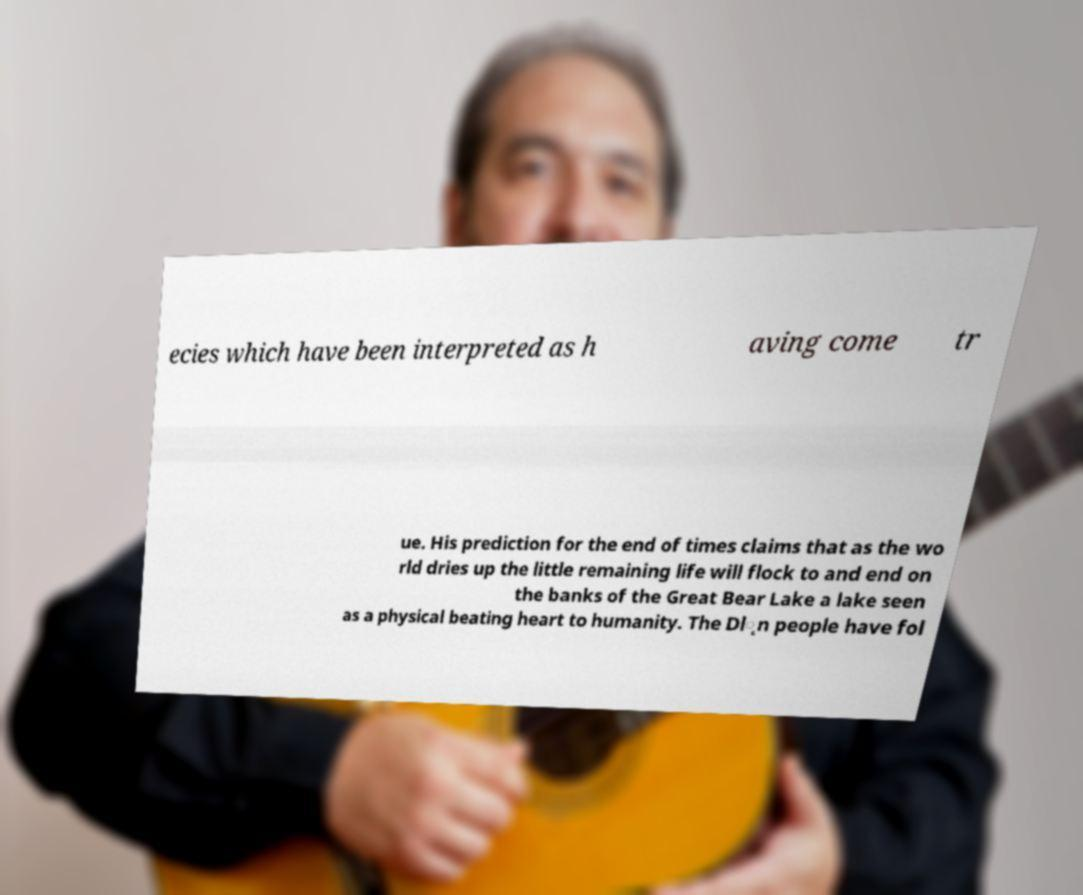What messages or text are displayed in this image? I need them in a readable, typed format. ecies which have been interpreted as h aving come tr ue. His prediction for the end of times claims that as the wo rld dries up the little remaining life will flock to and end on the banks of the Great Bear Lake a lake seen as a physical beating heart to humanity. The Dl̨n people have fol 